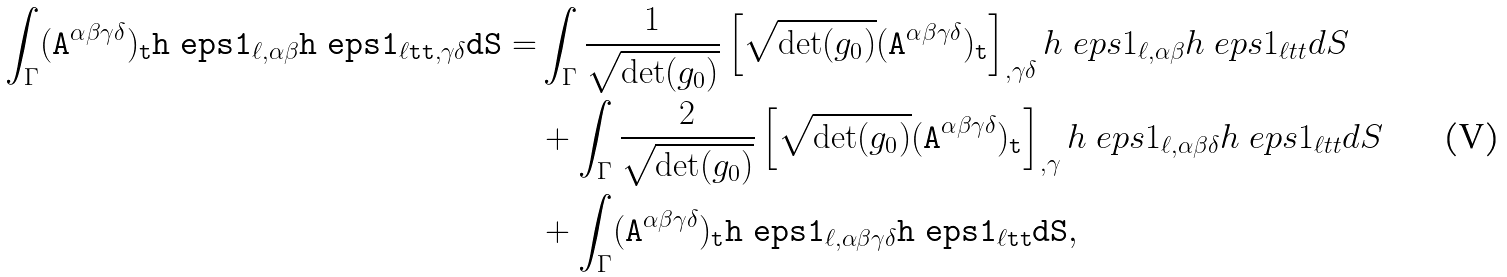Convert formula to latex. <formula><loc_0><loc_0><loc_500><loc_500>\int _ { \Gamma } ( \tt A ^ { \alpha \beta \gamma \delta } ) _ { t } h ^ { \ } e p s 1 _ { \ell , \alpha \beta } h ^ { \ } e p s 1 _ { \ell t t , \gamma \delta } d S = & \int _ { \Gamma } \frac { 1 } { \sqrt { \det ( g _ { 0 } ) } } \left [ \sqrt { \det ( g _ { 0 } ) } ( \tt A ^ { \alpha \beta \gamma \delta } ) _ { t } \right ] _ { , \gamma \delta } h ^ { \ } e p s 1 _ { \ell , \alpha \beta } h ^ { \ } e p s 1 _ { \ell t t } d S \\ & + \int _ { \Gamma } \frac { 2 } { \sqrt { \det ( g _ { 0 } ) } } \left [ \sqrt { \det ( g _ { 0 } ) } ( \tt A ^ { \alpha \beta \gamma \delta } ) _ { t } \right ] _ { , \gamma } h ^ { \ } e p s 1 _ { \ell , \alpha \beta \delta } h ^ { \ } e p s 1 _ { \ell t t } d S \\ & + \int _ { \Gamma } ( \tt A ^ { \alpha \beta \gamma \delta } ) _ { t } h ^ { \ } e p s 1 _ { \ell , \alpha \beta \gamma \delta } h ^ { \ } e p s 1 _ { \ell t t } d S ,</formula> 